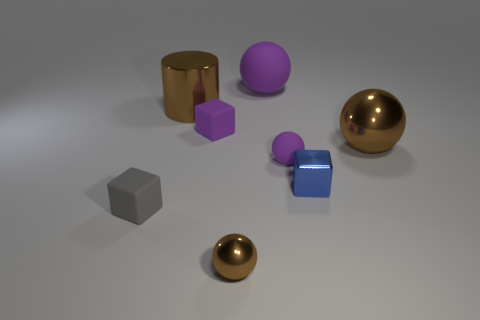The matte sphere that is the same color as the big matte thing is what size?
Offer a very short reply. Small. What number of other objects are the same color as the tiny metal sphere?
Make the answer very short. 2. Does the big cylinder have the same color as the tiny metallic ball?
Offer a very short reply. Yes. What number of other things are the same shape as the tiny gray object?
Your answer should be compact. 2. There is a cube that is behind the brown shiny object that is right of the small brown thing; what size is it?
Your response must be concise. Small. There is a brown thing that is the same size as the gray rubber cube; what material is it?
Ensure brevity in your answer.  Metal. Are there any small balls that have the same material as the tiny blue thing?
Keep it short and to the point. Yes. The block right of the purple thing in front of the tiny purple rubber object behind the big shiny ball is what color?
Offer a very short reply. Blue. There is a shiny object in front of the tiny blue thing; is it the same color as the large metallic thing that is to the right of the big brown metal cylinder?
Your response must be concise. Yes. Is there anything else of the same color as the large metal cylinder?
Provide a succinct answer. Yes. 